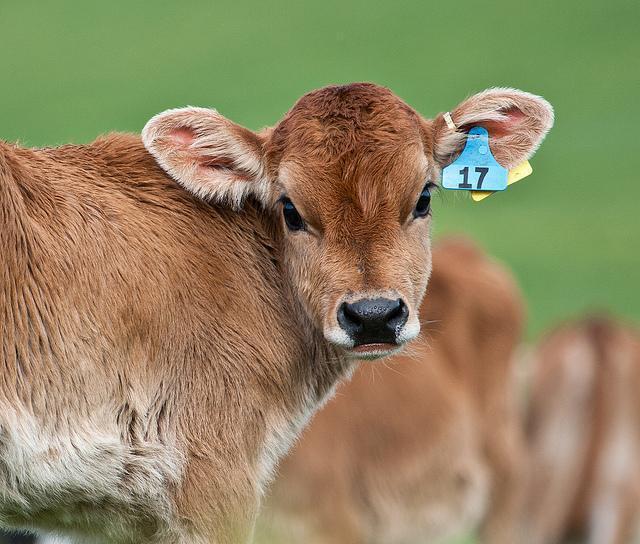How many tags does the calf have on it's ear?
Give a very brief answer. 2. How many cows are there?
Give a very brief answer. 2. 